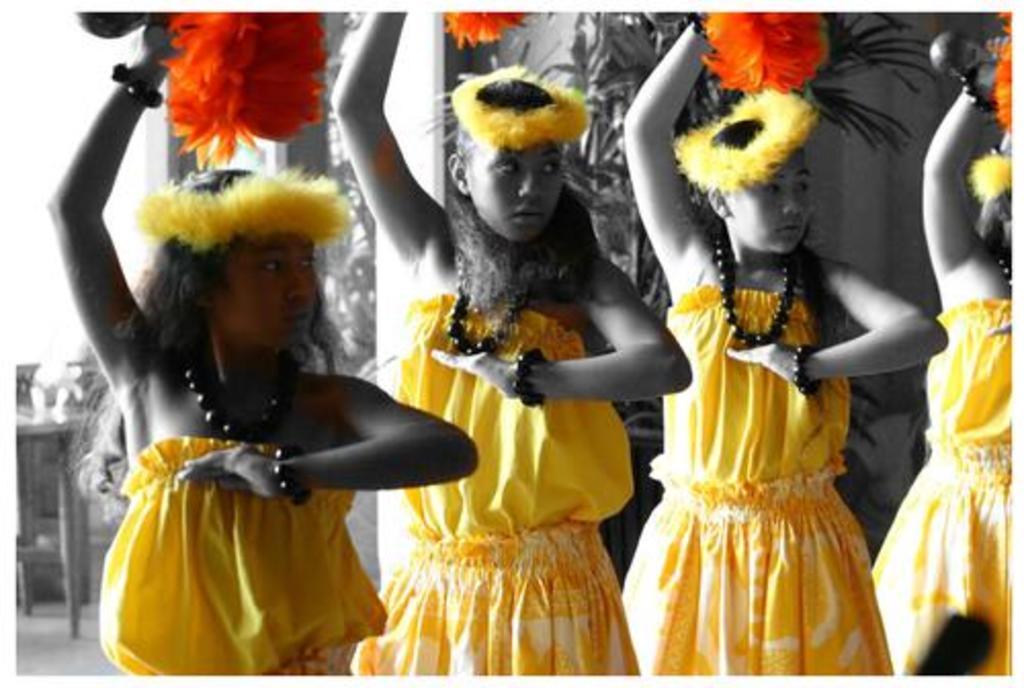Can you describe this image briefly? In the center of the image we can see four people standing. They are wearing same costumes. On the left there is a table. In the background there is a wall and we can see plants. 